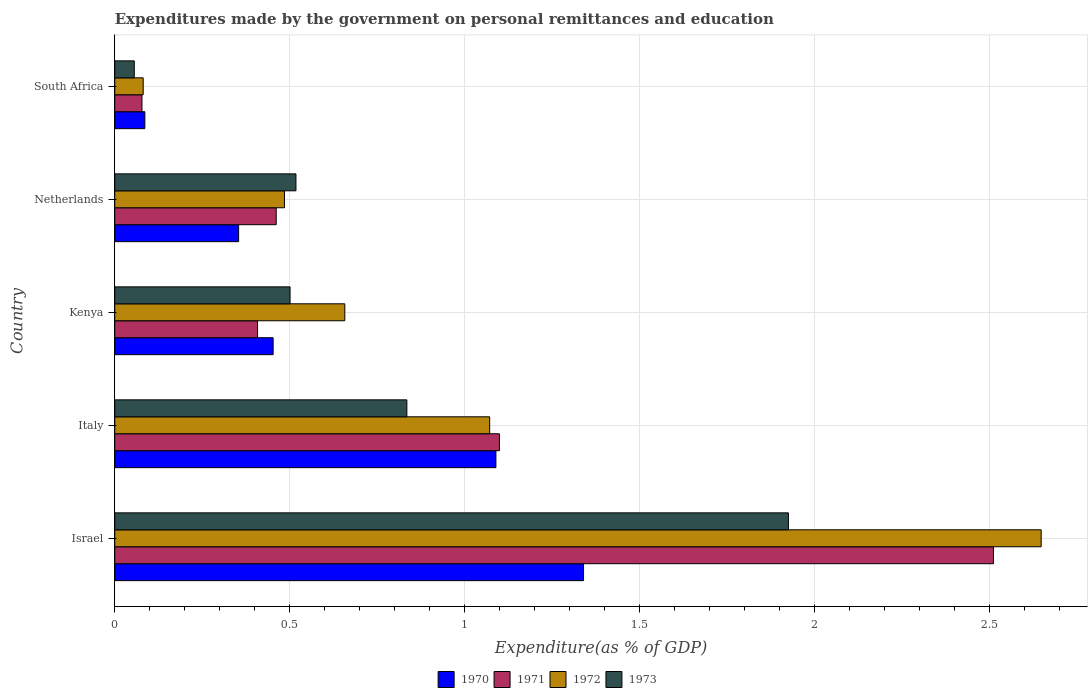How many different coloured bars are there?
Keep it short and to the point. 4. Are the number of bars per tick equal to the number of legend labels?
Your answer should be compact. Yes. Are the number of bars on each tick of the Y-axis equal?
Ensure brevity in your answer.  Yes. How many bars are there on the 3rd tick from the bottom?
Make the answer very short. 4. What is the label of the 1st group of bars from the top?
Keep it short and to the point. South Africa. What is the expenditures made by the government on personal remittances and education in 1971 in Israel?
Your answer should be very brief. 2.51. Across all countries, what is the maximum expenditures made by the government on personal remittances and education in 1972?
Provide a succinct answer. 2.65. Across all countries, what is the minimum expenditures made by the government on personal remittances and education in 1972?
Give a very brief answer. 0.08. In which country was the expenditures made by the government on personal remittances and education in 1970 minimum?
Give a very brief answer. South Africa. What is the total expenditures made by the government on personal remittances and education in 1971 in the graph?
Make the answer very short. 4.56. What is the difference between the expenditures made by the government on personal remittances and education in 1973 in Israel and that in Kenya?
Keep it short and to the point. 1.42. What is the difference between the expenditures made by the government on personal remittances and education in 1972 in Kenya and the expenditures made by the government on personal remittances and education in 1973 in Netherlands?
Ensure brevity in your answer.  0.14. What is the average expenditures made by the government on personal remittances and education in 1972 per country?
Make the answer very short. 0.99. What is the difference between the expenditures made by the government on personal remittances and education in 1970 and expenditures made by the government on personal remittances and education in 1971 in Netherlands?
Your answer should be compact. -0.11. What is the ratio of the expenditures made by the government on personal remittances and education in 1972 in Israel to that in South Africa?
Give a very brief answer. 32.58. What is the difference between the highest and the second highest expenditures made by the government on personal remittances and education in 1972?
Provide a short and direct response. 1.58. What is the difference between the highest and the lowest expenditures made by the government on personal remittances and education in 1972?
Your answer should be very brief. 2.57. In how many countries, is the expenditures made by the government on personal remittances and education in 1970 greater than the average expenditures made by the government on personal remittances and education in 1970 taken over all countries?
Give a very brief answer. 2. Is the sum of the expenditures made by the government on personal remittances and education in 1971 in Netherlands and South Africa greater than the maximum expenditures made by the government on personal remittances and education in 1973 across all countries?
Your response must be concise. No. What does the 1st bar from the top in Israel represents?
Ensure brevity in your answer.  1973. What does the 2nd bar from the bottom in Kenya represents?
Your answer should be very brief. 1971. How many bars are there?
Offer a terse response. 20. Are all the bars in the graph horizontal?
Your response must be concise. Yes. What is the difference between two consecutive major ticks on the X-axis?
Keep it short and to the point. 0.5. Are the values on the major ticks of X-axis written in scientific E-notation?
Your answer should be very brief. No. Does the graph contain any zero values?
Give a very brief answer. No. How many legend labels are there?
Provide a succinct answer. 4. What is the title of the graph?
Provide a succinct answer. Expenditures made by the government on personal remittances and education. What is the label or title of the X-axis?
Your response must be concise. Expenditure(as % of GDP). What is the Expenditure(as % of GDP) in 1970 in Israel?
Make the answer very short. 1.34. What is the Expenditure(as % of GDP) in 1971 in Israel?
Offer a very short reply. 2.51. What is the Expenditure(as % of GDP) of 1972 in Israel?
Offer a very short reply. 2.65. What is the Expenditure(as % of GDP) in 1973 in Israel?
Your response must be concise. 1.93. What is the Expenditure(as % of GDP) of 1970 in Italy?
Your answer should be very brief. 1.09. What is the Expenditure(as % of GDP) of 1971 in Italy?
Make the answer very short. 1.1. What is the Expenditure(as % of GDP) of 1972 in Italy?
Keep it short and to the point. 1.07. What is the Expenditure(as % of GDP) of 1973 in Italy?
Make the answer very short. 0.84. What is the Expenditure(as % of GDP) of 1970 in Kenya?
Your answer should be very brief. 0.45. What is the Expenditure(as % of GDP) in 1971 in Kenya?
Keep it short and to the point. 0.41. What is the Expenditure(as % of GDP) of 1972 in Kenya?
Ensure brevity in your answer.  0.66. What is the Expenditure(as % of GDP) in 1973 in Kenya?
Provide a succinct answer. 0.5. What is the Expenditure(as % of GDP) in 1970 in Netherlands?
Your response must be concise. 0.35. What is the Expenditure(as % of GDP) of 1971 in Netherlands?
Ensure brevity in your answer.  0.46. What is the Expenditure(as % of GDP) of 1972 in Netherlands?
Your answer should be very brief. 0.49. What is the Expenditure(as % of GDP) in 1973 in Netherlands?
Make the answer very short. 0.52. What is the Expenditure(as % of GDP) in 1970 in South Africa?
Your answer should be very brief. 0.09. What is the Expenditure(as % of GDP) of 1971 in South Africa?
Your answer should be compact. 0.08. What is the Expenditure(as % of GDP) in 1972 in South Africa?
Offer a very short reply. 0.08. What is the Expenditure(as % of GDP) in 1973 in South Africa?
Your response must be concise. 0.06. Across all countries, what is the maximum Expenditure(as % of GDP) of 1970?
Keep it short and to the point. 1.34. Across all countries, what is the maximum Expenditure(as % of GDP) in 1971?
Keep it short and to the point. 2.51. Across all countries, what is the maximum Expenditure(as % of GDP) in 1972?
Your answer should be compact. 2.65. Across all countries, what is the maximum Expenditure(as % of GDP) in 1973?
Your response must be concise. 1.93. Across all countries, what is the minimum Expenditure(as % of GDP) of 1970?
Provide a succinct answer. 0.09. Across all countries, what is the minimum Expenditure(as % of GDP) in 1971?
Provide a short and direct response. 0.08. Across all countries, what is the minimum Expenditure(as % of GDP) in 1972?
Provide a short and direct response. 0.08. Across all countries, what is the minimum Expenditure(as % of GDP) of 1973?
Offer a terse response. 0.06. What is the total Expenditure(as % of GDP) in 1970 in the graph?
Offer a very short reply. 3.32. What is the total Expenditure(as % of GDP) of 1971 in the graph?
Your response must be concise. 4.56. What is the total Expenditure(as % of GDP) in 1972 in the graph?
Provide a succinct answer. 4.94. What is the total Expenditure(as % of GDP) in 1973 in the graph?
Provide a short and direct response. 3.84. What is the difference between the Expenditure(as % of GDP) in 1970 in Israel and that in Italy?
Your response must be concise. 0.25. What is the difference between the Expenditure(as % of GDP) in 1971 in Israel and that in Italy?
Your answer should be very brief. 1.41. What is the difference between the Expenditure(as % of GDP) in 1972 in Israel and that in Italy?
Offer a very short reply. 1.58. What is the difference between the Expenditure(as % of GDP) in 1970 in Israel and that in Kenya?
Give a very brief answer. 0.89. What is the difference between the Expenditure(as % of GDP) in 1971 in Israel and that in Kenya?
Keep it short and to the point. 2.1. What is the difference between the Expenditure(as % of GDP) in 1972 in Israel and that in Kenya?
Keep it short and to the point. 1.99. What is the difference between the Expenditure(as % of GDP) in 1973 in Israel and that in Kenya?
Your response must be concise. 1.42. What is the difference between the Expenditure(as % of GDP) in 1970 in Israel and that in Netherlands?
Keep it short and to the point. 0.99. What is the difference between the Expenditure(as % of GDP) in 1971 in Israel and that in Netherlands?
Your response must be concise. 2.05. What is the difference between the Expenditure(as % of GDP) of 1972 in Israel and that in Netherlands?
Offer a terse response. 2.16. What is the difference between the Expenditure(as % of GDP) of 1973 in Israel and that in Netherlands?
Offer a very short reply. 1.41. What is the difference between the Expenditure(as % of GDP) in 1970 in Israel and that in South Africa?
Provide a short and direct response. 1.25. What is the difference between the Expenditure(as % of GDP) in 1971 in Israel and that in South Africa?
Your response must be concise. 2.43. What is the difference between the Expenditure(as % of GDP) in 1972 in Israel and that in South Africa?
Provide a succinct answer. 2.57. What is the difference between the Expenditure(as % of GDP) of 1973 in Israel and that in South Africa?
Give a very brief answer. 1.87. What is the difference between the Expenditure(as % of GDP) of 1970 in Italy and that in Kenya?
Provide a succinct answer. 0.64. What is the difference between the Expenditure(as % of GDP) in 1971 in Italy and that in Kenya?
Make the answer very short. 0.69. What is the difference between the Expenditure(as % of GDP) in 1972 in Italy and that in Kenya?
Keep it short and to the point. 0.41. What is the difference between the Expenditure(as % of GDP) in 1973 in Italy and that in Kenya?
Your answer should be very brief. 0.33. What is the difference between the Expenditure(as % of GDP) in 1970 in Italy and that in Netherlands?
Keep it short and to the point. 0.74. What is the difference between the Expenditure(as % of GDP) in 1971 in Italy and that in Netherlands?
Your response must be concise. 0.64. What is the difference between the Expenditure(as % of GDP) of 1972 in Italy and that in Netherlands?
Ensure brevity in your answer.  0.59. What is the difference between the Expenditure(as % of GDP) in 1973 in Italy and that in Netherlands?
Offer a very short reply. 0.32. What is the difference between the Expenditure(as % of GDP) of 1971 in Italy and that in South Africa?
Give a very brief answer. 1.02. What is the difference between the Expenditure(as % of GDP) of 1972 in Italy and that in South Africa?
Provide a short and direct response. 0.99. What is the difference between the Expenditure(as % of GDP) in 1973 in Italy and that in South Africa?
Provide a short and direct response. 0.78. What is the difference between the Expenditure(as % of GDP) of 1970 in Kenya and that in Netherlands?
Your response must be concise. 0.1. What is the difference between the Expenditure(as % of GDP) of 1971 in Kenya and that in Netherlands?
Your response must be concise. -0.05. What is the difference between the Expenditure(as % of GDP) of 1972 in Kenya and that in Netherlands?
Your answer should be compact. 0.17. What is the difference between the Expenditure(as % of GDP) in 1973 in Kenya and that in Netherlands?
Make the answer very short. -0.02. What is the difference between the Expenditure(as % of GDP) of 1970 in Kenya and that in South Africa?
Your answer should be very brief. 0.37. What is the difference between the Expenditure(as % of GDP) of 1971 in Kenya and that in South Africa?
Your answer should be very brief. 0.33. What is the difference between the Expenditure(as % of GDP) in 1972 in Kenya and that in South Africa?
Provide a short and direct response. 0.58. What is the difference between the Expenditure(as % of GDP) of 1973 in Kenya and that in South Africa?
Ensure brevity in your answer.  0.45. What is the difference between the Expenditure(as % of GDP) in 1970 in Netherlands and that in South Africa?
Offer a terse response. 0.27. What is the difference between the Expenditure(as % of GDP) of 1971 in Netherlands and that in South Africa?
Your answer should be compact. 0.38. What is the difference between the Expenditure(as % of GDP) in 1972 in Netherlands and that in South Africa?
Ensure brevity in your answer.  0.4. What is the difference between the Expenditure(as % of GDP) of 1973 in Netherlands and that in South Africa?
Give a very brief answer. 0.46. What is the difference between the Expenditure(as % of GDP) of 1970 in Israel and the Expenditure(as % of GDP) of 1971 in Italy?
Give a very brief answer. 0.24. What is the difference between the Expenditure(as % of GDP) of 1970 in Israel and the Expenditure(as % of GDP) of 1972 in Italy?
Provide a succinct answer. 0.27. What is the difference between the Expenditure(as % of GDP) in 1970 in Israel and the Expenditure(as % of GDP) in 1973 in Italy?
Your answer should be very brief. 0.51. What is the difference between the Expenditure(as % of GDP) in 1971 in Israel and the Expenditure(as % of GDP) in 1972 in Italy?
Your answer should be very brief. 1.44. What is the difference between the Expenditure(as % of GDP) of 1971 in Israel and the Expenditure(as % of GDP) of 1973 in Italy?
Give a very brief answer. 1.68. What is the difference between the Expenditure(as % of GDP) in 1972 in Israel and the Expenditure(as % of GDP) in 1973 in Italy?
Your answer should be compact. 1.81. What is the difference between the Expenditure(as % of GDP) of 1970 in Israel and the Expenditure(as % of GDP) of 1971 in Kenya?
Offer a very short reply. 0.93. What is the difference between the Expenditure(as % of GDP) in 1970 in Israel and the Expenditure(as % of GDP) in 1972 in Kenya?
Provide a succinct answer. 0.68. What is the difference between the Expenditure(as % of GDP) of 1970 in Israel and the Expenditure(as % of GDP) of 1973 in Kenya?
Your response must be concise. 0.84. What is the difference between the Expenditure(as % of GDP) in 1971 in Israel and the Expenditure(as % of GDP) in 1972 in Kenya?
Give a very brief answer. 1.85. What is the difference between the Expenditure(as % of GDP) of 1971 in Israel and the Expenditure(as % of GDP) of 1973 in Kenya?
Make the answer very short. 2.01. What is the difference between the Expenditure(as % of GDP) in 1972 in Israel and the Expenditure(as % of GDP) in 1973 in Kenya?
Your response must be concise. 2.15. What is the difference between the Expenditure(as % of GDP) in 1970 in Israel and the Expenditure(as % of GDP) in 1971 in Netherlands?
Your response must be concise. 0.88. What is the difference between the Expenditure(as % of GDP) in 1970 in Israel and the Expenditure(as % of GDP) in 1972 in Netherlands?
Keep it short and to the point. 0.85. What is the difference between the Expenditure(as % of GDP) in 1970 in Israel and the Expenditure(as % of GDP) in 1973 in Netherlands?
Your response must be concise. 0.82. What is the difference between the Expenditure(as % of GDP) in 1971 in Israel and the Expenditure(as % of GDP) in 1972 in Netherlands?
Provide a short and direct response. 2.03. What is the difference between the Expenditure(as % of GDP) of 1971 in Israel and the Expenditure(as % of GDP) of 1973 in Netherlands?
Your response must be concise. 1.99. What is the difference between the Expenditure(as % of GDP) of 1972 in Israel and the Expenditure(as % of GDP) of 1973 in Netherlands?
Offer a very short reply. 2.13. What is the difference between the Expenditure(as % of GDP) in 1970 in Israel and the Expenditure(as % of GDP) in 1971 in South Africa?
Provide a short and direct response. 1.26. What is the difference between the Expenditure(as % of GDP) of 1970 in Israel and the Expenditure(as % of GDP) of 1972 in South Africa?
Your answer should be compact. 1.26. What is the difference between the Expenditure(as % of GDP) in 1970 in Israel and the Expenditure(as % of GDP) in 1973 in South Africa?
Ensure brevity in your answer.  1.28. What is the difference between the Expenditure(as % of GDP) of 1971 in Israel and the Expenditure(as % of GDP) of 1972 in South Africa?
Your answer should be compact. 2.43. What is the difference between the Expenditure(as % of GDP) in 1971 in Israel and the Expenditure(as % of GDP) in 1973 in South Africa?
Provide a succinct answer. 2.46. What is the difference between the Expenditure(as % of GDP) in 1972 in Israel and the Expenditure(as % of GDP) in 1973 in South Africa?
Offer a very short reply. 2.59. What is the difference between the Expenditure(as % of GDP) in 1970 in Italy and the Expenditure(as % of GDP) in 1971 in Kenya?
Offer a very short reply. 0.68. What is the difference between the Expenditure(as % of GDP) of 1970 in Italy and the Expenditure(as % of GDP) of 1972 in Kenya?
Make the answer very short. 0.43. What is the difference between the Expenditure(as % of GDP) of 1970 in Italy and the Expenditure(as % of GDP) of 1973 in Kenya?
Ensure brevity in your answer.  0.59. What is the difference between the Expenditure(as % of GDP) of 1971 in Italy and the Expenditure(as % of GDP) of 1972 in Kenya?
Ensure brevity in your answer.  0.44. What is the difference between the Expenditure(as % of GDP) in 1971 in Italy and the Expenditure(as % of GDP) in 1973 in Kenya?
Provide a succinct answer. 0.6. What is the difference between the Expenditure(as % of GDP) of 1972 in Italy and the Expenditure(as % of GDP) of 1973 in Kenya?
Your response must be concise. 0.57. What is the difference between the Expenditure(as % of GDP) in 1970 in Italy and the Expenditure(as % of GDP) in 1971 in Netherlands?
Your answer should be very brief. 0.63. What is the difference between the Expenditure(as % of GDP) of 1970 in Italy and the Expenditure(as % of GDP) of 1972 in Netherlands?
Make the answer very short. 0.6. What is the difference between the Expenditure(as % of GDP) in 1970 in Italy and the Expenditure(as % of GDP) in 1973 in Netherlands?
Ensure brevity in your answer.  0.57. What is the difference between the Expenditure(as % of GDP) of 1971 in Italy and the Expenditure(as % of GDP) of 1972 in Netherlands?
Provide a short and direct response. 0.61. What is the difference between the Expenditure(as % of GDP) of 1971 in Italy and the Expenditure(as % of GDP) of 1973 in Netherlands?
Provide a short and direct response. 0.58. What is the difference between the Expenditure(as % of GDP) in 1972 in Italy and the Expenditure(as % of GDP) in 1973 in Netherlands?
Ensure brevity in your answer.  0.55. What is the difference between the Expenditure(as % of GDP) of 1970 in Italy and the Expenditure(as % of GDP) of 1971 in South Africa?
Provide a short and direct response. 1.01. What is the difference between the Expenditure(as % of GDP) of 1970 in Italy and the Expenditure(as % of GDP) of 1972 in South Africa?
Keep it short and to the point. 1.01. What is the difference between the Expenditure(as % of GDP) in 1970 in Italy and the Expenditure(as % of GDP) in 1973 in South Africa?
Offer a terse response. 1.03. What is the difference between the Expenditure(as % of GDP) of 1971 in Italy and the Expenditure(as % of GDP) of 1972 in South Africa?
Offer a very short reply. 1.02. What is the difference between the Expenditure(as % of GDP) of 1971 in Italy and the Expenditure(as % of GDP) of 1973 in South Africa?
Your answer should be compact. 1.04. What is the difference between the Expenditure(as % of GDP) in 1972 in Italy and the Expenditure(as % of GDP) in 1973 in South Africa?
Ensure brevity in your answer.  1.02. What is the difference between the Expenditure(as % of GDP) of 1970 in Kenya and the Expenditure(as % of GDP) of 1971 in Netherlands?
Provide a short and direct response. -0.01. What is the difference between the Expenditure(as % of GDP) of 1970 in Kenya and the Expenditure(as % of GDP) of 1972 in Netherlands?
Offer a very short reply. -0.03. What is the difference between the Expenditure(as % of GDP) in 1970 in Kenya and the Expenditure(as % of GDP) in 1973 in Netherlands?
Your answer should be compact. -0.07. What is the difference between the Expenditure(as % of GDP) of 1971 in Kenya and the Expenditure(as % of GDP) of 1972 in Netherlands?
Give a very brief answer. -0.08. What is the difference between the Expenditure(as % of GDP) of 1971 in Kenya and the Expenditure(as % of GDP) of 1973 in Netherlands?
Make the answer very short. -0.11. What is the difference between the Expenditure(as % of GDP) in 1972 in Kenya and the Expenditure(as % of GDP) in 1973 in Netherlands?
Make the answer very short. 0.14. What is the difference between the Expenditure(as % of GDP) in 1970 in Kenya and the Expenditure(as % of GDP) in 1972 in South Africa?
Offer a terse response. 0.37. What is the difference between the Expenditure(as % of GDP) of 1970 in Kenya and the Expenditure(as % of GDP) of 1973 in South Africa?
Give a very brief answer. 0.4. What is the difference between the Expenditure(as % of GDP) in 1971 in Kenya and the Expenditure(as % of GDP) in 1972 in South Africa?
Your answer should be very brief. 0.33. What is the difference between the Expenditure(as % of GDP) of 1971 in Kenya and the Expenditure(as % of GDP) of 1973 in South Africa?
Provide a succinct answer. 0.35. What is the difference between the Expenditure(as % of GDP) of 1972 in Kenya and the Expenditure(as % of GDP) of 1973 in South Africa?
Give a very brief answer. 0.6. What is the difference between the Expenditure(as % of GDP) in 1970 in Netherlands and the Expenditure(as % of GDP) in 1971 in South Africa?
Offer a very short reply. 0.28. What is the difference between the Expenditure(as % of GDP) of 1970 in Netherlands and the Expenditure(as % of GDP) of 1972 in South Africa?
Provide a succinct answer. 0.27. What is the difference between the Expenditure(as % of GDP) of 1970 in Netherlands and the Expenditure(as % of GDP) of 1973 in South Africa?
Offer a terse response. 0.3. What is the difference between the Expenditure(as % of GDP) in 1971 in Netherlands and the Expenditure(as % of GDP) in 1972 in South Africa?
Offer a very short reply. 0.38. What is the difference between the Expenditure(as % of GDP) in 1971 in Netherlands and the Expenditure(as % of GDP) in 1973 in South Africa?
Your answer should be very brief. 0.41. What is the difference between the Expenditure(as % of GDP) in 1972 in Netherlands and the Expenditure(as % of GDP) in 1973 in South Africa?
Your answer should be compact. 0.43. What is the average Expenditure(as % of GDP) of 1970 per country?
Offer a terse response. 0.66. What is the average Expenditure(as % of GDP) of 1971 per country?
Provide a succinct answer. 0.91. What is the average Expenditure(as % of GDP) in 1972 per country?
Offer a terse response. 0.99. What is the average Expenditure(as % of GDP) of 1973 per country?
Provide a short and direct response. 0.77. What is the difference between the Expenditure(as % of GDP) of 1970 and Expenditure(as % of GDP) of 1971 in Israel?
Keep it short and to the point. -1.17. What is the difference between the Expenditure(as % of GDP) of 1970 and Expenditure(as % of GDP) of 1972 in Israel?
Provide a succinct answer. -1.31. What is the difference between the Expenditure(as % of GDP) in 1970 and Expenditure(as % of GDP) in 1973 in Israel?
Give a very brief answer. -0.59. What is the difference between the Expenditure(as % of GDP) in 1971 and Expenditure(as % of GDP) in 1972 in Israel?
Offer a very short reply. -0.14. What is the difference between the Expenditure(as % of GDP) in 1971 and Expenditure(as % of GDP) in 1973 in Israel?
Provide a short and direct response. 0.59. What is the difference between the Expenditure(as % of GDP) of 1972 and Expenditure(as % of GDP) of 1973 in Israel?
Give a very brief answer. 0.72. What is the difference between the Expenditure(as % of GDP) in 1970 and Expenditure(as % of GDP) in 1971 in Italy?
Make the answer very short. -0.01. What is the difference between the Expenditure(as % of GDP) in 1970 and Expenditure(as % of GDP) in 1972 in Italy?
Provide a succinct answer. 0.02. What is the difference between the Expenditure(as % of GDP) of 1970 and Expenditure(as % of GDP) of 1973 in Italy?
Ensure brevity in your answer.  0.25. What is the difference between the Expenditure(as % of GDP) in 1971 and Expenditure(as % of GDP) in 1972 in Italy?
Provide a succinct answer. 0.03. What is the difference between the Expenditure(as % of GDP) of 1971 and Expenditure(as % of GDP) of 1973 in Italy?
Provide a short and direct response. 0.26. What is the difference between the Expenditure(as % of GDP) in 1972 and Expenditure(as % of GDP) in 1973 in Italy?
Your response must be concise. 0.24. What is the difference between the Expenditure(as % of GDP) in 1970 and Expenditure(as % of GDP) in 1971 in Kenya?
Your response must be concise. 0.04. What is the difference between the Expenditure(as % of GDP) of 1970 and Expenditure(as % of GDP) of 1972 in Kenya?
Make the answer very short. -0.2. What is the difference between the Expenditure(as % of GDP) of 1970 and Expenditure(as % of GDP) of 1973 in Kenya?
Offer a very short reply. -0.05. What is the difference between the Expenditure(as % of GDP) of 1971 and Expenditure(as % of GDP) of 1972 in Kenya?
Offer a very short reply. -0.25. What is the difference between the Expenditure(as % of GDP) of 1971 and Expenditure(as % of GDP) of 1973 in Kenya?
Give a very brief answer. -0.09. What is the difference between the Expenditure(as % of GDP) in 1972 and Expenditure(as % of GDP) in 1973 in Kenya?
Give a very brief answer. 0.16. What is the difference between the Expenditure(as % of GDP) of 1970 and Expenditure(as % of GDP) of 1971 in Netherlands?
Offer a terse response. -0.11. What is the difference between the Expenditure(as % of GDP) in 1970 and Expenditure(as % of GDP) in 1972 in Netherlands?
Offer a terse response. -0.13. What is the difference between the Expenditure(as % of GDP) of 1970 and Expenditure(as % of GDP) of 1973 in Netherlands?
Offer a terse response. -0.16. What is the difference between the Expenditure(as % of GDP) of 1971 and Expenditure(as % of GDP) of 1972 in Netherlands?
Ensure brevity in your answer.  -0.02. What is the difference between the Expenditure(as % of GDP) in 1971 and Expenditure(as % of GDP) in 1973 in Netherlands?
Provide a short and direct response. -0.06. What is the difference between the Expenditure(as % of GDP) of 1972 and Expenditure(as % of GDP) of 1973 in Netherlands?
Offer a terse response. -0.03. What is the difference between the Expenditure(as % of GDP) of 1970 and Expenditure(as % of GDP) of 1971 in South Africa?
Provide a short and direct response. 0.01. What is the difference between the Expenditure(as % of GDP) of 1970 and Expenditure(as % of GDP) of 1972 in South Africa?
Provide a succinct answer. 0. What is the difference between the Expenditure(as % of GDP) of 1970 and Expenditure(as % of GDP) of 1973 in South Africa?
Provide a short and direct response. 0.03. What is the difference between the Expenditure(as % of GDP) of 1971 and Expenditure(as % of GDP) of 1972 in South Africa?
Your answer should be very brief. -0. What is the difference between the Expenditure(as % of GDP) in 1971 and Expenditure(as % of GDP) in 1973 in South Africa?
Keep it short and to the point. 0.02. What is the difference between the Expenditure(as % of GDP) of 1972 and Expenditure(as % of GDP) of 1973 in South Africa?
Provide a short and direct response. 0.03. What is the ratio of the Expenditure(as % of GDP) of 1970 in Israel to that in Italy?
Ensure brevity in your answer.  1.23. What is the ratio of the Expenditure(as % of GDP) of 1971 in Israel to that in Italy?
Make the answer very short. 2.28. What is the ratio of the Expenditure(as % of GDP) of 1972 in Israel to that in Italy?
Ensure brevity in your answer.  2.47. What is the ratio of the Expenditure(as % of GDP) in 1973 in Israel to that in Italy?
Keep it short and to the point. 2.31. What is the ratio of the Expenditure(as % of GDP) in 1970 in Israel to that in Kenya?
Ensure brevity in your answer.  2.96. What is the ratio of the Expenditure(as % of GDP) in 1971 in Israel to that in Kenya?
Your answer should be very brief. 6.15. What is the ratio of the Expenditure(as % of GDP) in 1972 in Israel to that in Kenya?
Ensure brevity in your answer.  4.03. What is the ratio of the Expenditure(as % of GDP) in 1973 in Israel to that in Kenya?
Your response must be concise. 3.84. What is the ratio of the Expenditure(as % of GDP) in 1970 in Israel to that in Netherlands?
Your answer should be very brief. 3.78. What is the ratio of the Expenditure(as % of GDP) in 1971 in Israel to that in Netherlands?
Your answer should be compact. 5.44. What is the ratio of the Expenditure(as % of GDP) in 1972 in Israel to that in Netherlands?
Your response must be concise. 5.46. What is the ratio of the Expenditure(as % of GDP) of 1973 in Israel to that in Netherlands?
Your answer should be compact. 3.72. What is the ratio of the Expenditure(as % of GDP) in 1970 in Israel to that in South Africa?
Provide a short and direct response. 15.58. What is the ratio of the Expenditure(as % of GDP) in 1971 in Israel to that in South Africa?
Offer a very short reply. 32.29. What is the ratio of the Expenditure(as % of GDP) in 1972 in Israel to that in South Africa?
Ensure brevity in your answer.  32.58. What is the ratio of the Expenditure(as % of GDP) in 1973 in Israel to that in South Africa?
Provide a succinct answer. 34.5. What is the ratio of the Expenditure(as % of GDP) of 1970 in Italy to that in Kenya?
Give a very brief answer. 2.41. What is the ratio of the Expenditure(as % of GDP) of 1971 in Italy to that in Kenya?
Your response must be concise. 2.69. What is the ratio of the Expenditure(as % of GDP) of 1972 in Italy to that in Kenya?
Provide a succinct answer. 1.63. What is the ratio of the Expenditure(as % of GDP) of 1973 in Italy to that in Kenya?
Your response must be concise. 1.67. What is the ratio of the Expenditure(as % of GDP) in 1970 in Italy to that in Netherlands?
Provide a succinct answer. 3.08. What is the ratio of the Expenditure(as % of GDP) in 1971 in Italy to that in Netherlands?
Offer a terse response. 2.38. What is the ratio of the Expenditure(as % of GDP) in 1972 in Italy to that in Netherlands?
Your answer should be compact. 2.21. What is the ratio of the Expenditure(as % of GDP) of 1973 in Italy to that in Netherlands?
Keep it short and to the point. 1.61. What is the ratio of the Expenditure(as % of GDP) of 1970 in Italy to that in South Africa?
Provide a succinct answer. 12.67. What is the ratio of the Expenditure(as % of GDP) in 1971 in Italy to that in South Africa?
Your answer should be very brief. 14.13. What is the ratio of the Expenditure(as % of GDP) of 1972 in Italy to that in South Africa?
Offer a very short reply. 13.18. What is the ratio of the Expenditure(as % of GDP) in 1973 in Italy to that in South Africa?
Your response must be concise. 14.96. What is the ratio of the Expenditure(as % of GDP) of 1970 in Kenya to that in Netherlands?
Keep it short and to the point. 1.28. What is the ratio of the Expenditure(as % of GDP) in 1971 in Kenya to that in Netherlands?
Your answer should be very brief. 0.88. What is the ratio of the Expenditure(as % of GDP) in 1972 in Kenya to that in Netherlands?
Your answer should be very brief. 1.36. What is the ratio of the Expenditure(as % of GDP) of 1973 in Kenya to that in Netherlands?
Your answer should be compact. 0.97. What is the ratio of the Expenditure(as % of GDP) of 1970 in Kenya to that in South Africa?
Offer a terse response. 5.26. What is the ratio of the Expenditure(as % of GDP) of 1971 in Kenya to that in South Africa?
Ensure brevity in your answer.  5.25. What is the ratio of the Expenditure(as % of GDP) in 1972 in Kenya to that in South Africa?
Give a very brief answer. 8.09. What is the ratio of the Expenditure(as % of GDP) of 1973 in Kenya to that in South Africa?
Make the answer very short. 8.98. What is the ratio of the Expenditure(as % of GDP) of 1970 in Netherlands to that in South Africa?
Provide a short and direct response. 4.12. What is the ratio of the Expenditure(as % of GDP) of 1971 in Netherlands to that in South Africa?
Your response must be concise. 5.93. What is the ratio of the Expenditure(as % of GDP) of 1972 in Netherlands to that in South Africa?
Provide a succinct answer. 5.97. What is the ratio of the Expenditure(as % of GDP) in 1973 in Netherlands to that in South Africa?
Keep it short and to the point. 9.28. What is the difference between the highest and the second highest Expenditure(as % of GDP) of 1970?
Offer a terse response. 0.25. What is the difference between the highest and the second highest Expenditure(as % of GDP) in 1971?
Provide a succinct answer. 1.41. What is the difference between the highest and the second highest Expenditure(as % of GDP) in 1972?
Make the answer very short. 1.58. What is the difference between the highest and the second highest Expenditure(as % of GDP) in 1973?
Give a very brief answer. 1.09. What is the difference between the highest and the lowest Expenditure(as % of GDP) of 1970?
Ensure brevity in your answer.  1.25. What is the difference between the highest and the lowest Expenditure(as % of GDP) in 1971?
Give a very brief answer. 2.43. What is the difference between the highest and the lowest Expenditure(as % of GDP) in 1972?
Offer a terse response. 2.57. What is the difference between the highest and the lowest Expenditure(as % of GDP) in 1973?
Make the answer very short. 1.87. 